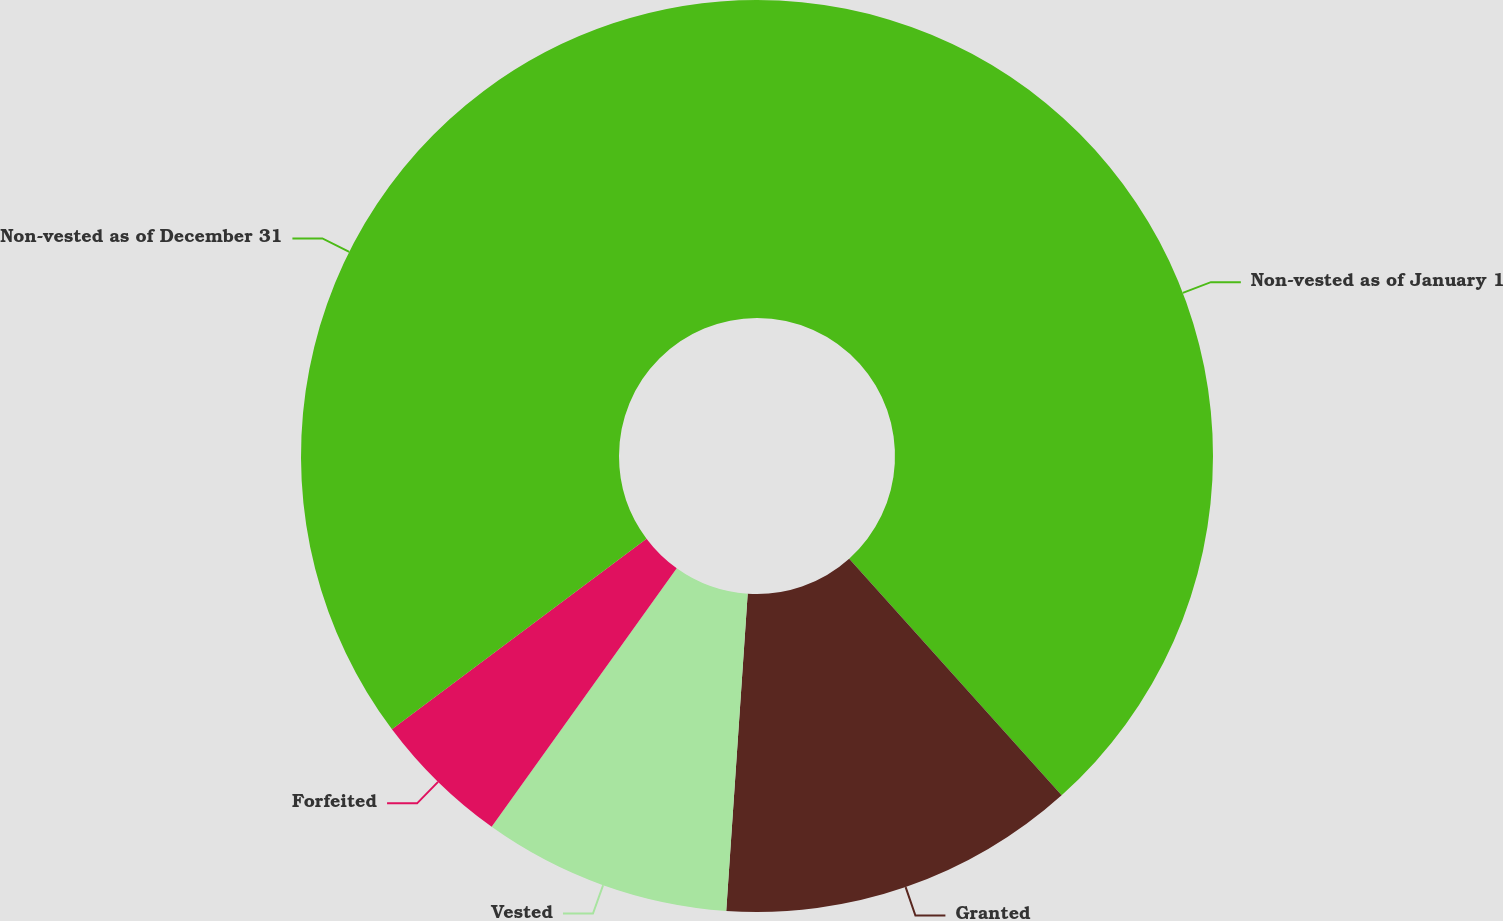<chart> <loc_0><loc_0><loc_500><loc_500><pie_chart><fcel>Non-vested as of January 1<fcel>Granted<fcel>Vested<fcel>Forfeited<fcel>Non-vested as of December 31<nl><fcel>38.36%<fcel>12.72%<fcel>8.81%<fcel>4.89%<fcel>35.23%<nl></chart> 